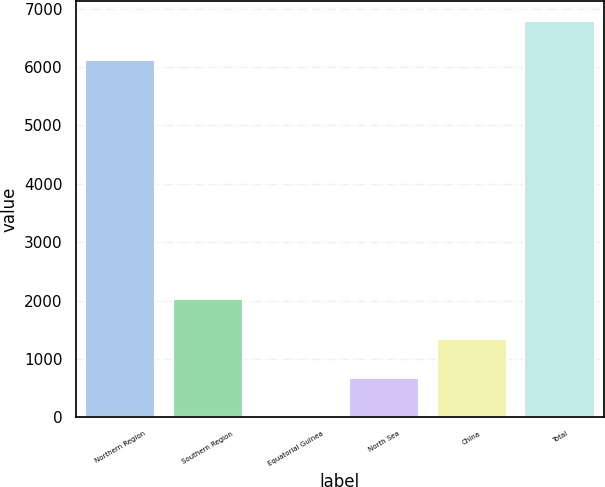Convert chart. <chart><loc_0><loc_0><loc_500><loc_500><bar_chart><fcel>Northern Region<fcel>Southern Region<fcel>Equatorial Guinea<fcel>North Sea<fcel>China<fcel>Total<nl><fcel>6119<fcel>2019.29<fcel>1.7<fcel>674.23<fcel>1346.76<fcel>6791.53<nl></chart> 